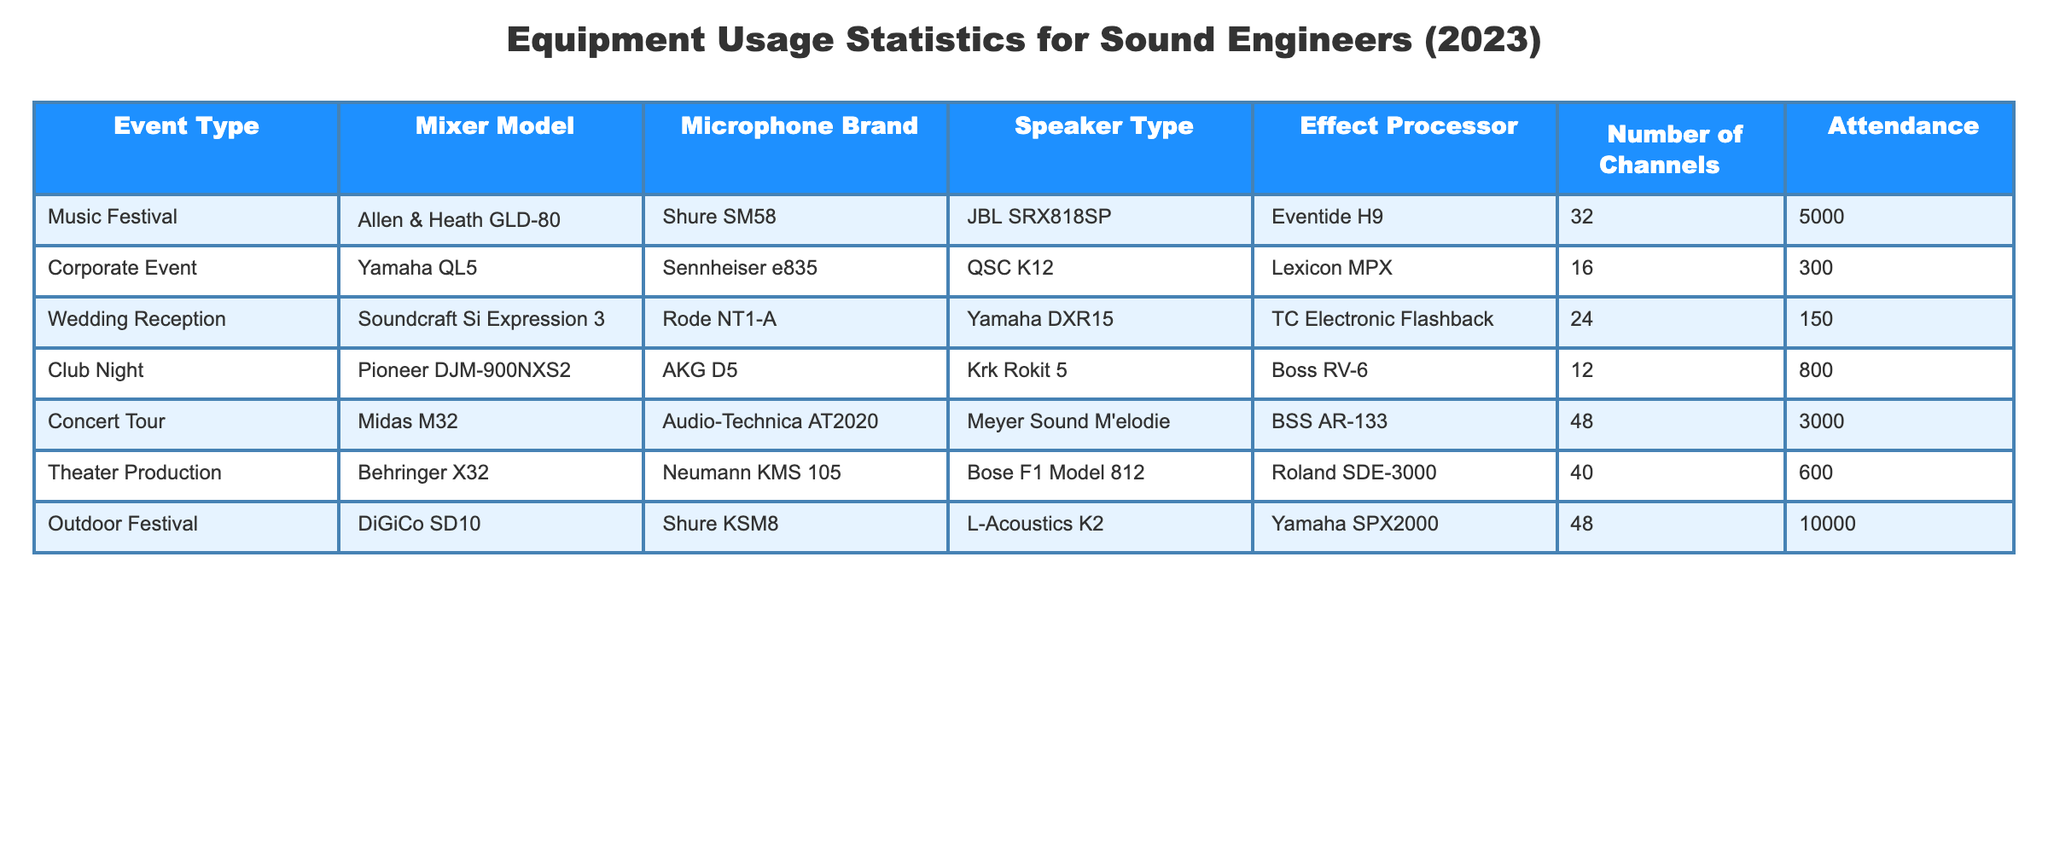What is the mixer model used for the Outdoor Festival? The table lists the equipment used for each event type. Looking at the row for the Outdoor Festival, the mixer model is DiGiCo SD10.
Answer: DiGiCo SD10 Which event type had the highest attendance? Attendance figures are presented in the table. By comparing the attendance numbers, the Outdoor Festival has the highest attendance of 10,000.
Answer: Outdoor Festival What is the average number of channels used across all events? To find the average, sum the number of channels used (32 + 16 + 24 + 12 + 48 + 40 + 48 = 220) and divide by the number of events (7). Therefore, the average is 220/7 = approximately 31.43.
Answer: 31.43 Is the microphone brand used for the Corporate Event Shure? The table specifies the microphone brand for each event. For the Corporate Event, the microphone brand is Sennheiser e835, which is not Shure.
Answer: No What is the difference in attendance between the Music Festival and the Concert Tour? To determine the difference, subtract the attendance of the Concert Tour (3000) from the Music Festival (5000). The difference is 5000 - 3000 = 2000.
Answer: 2000 Which effect processor was used for the Wedding Reception? Looking at the row for the Wedding Reception, the effect processor listed is TC Electronic Flashback.
Answer: TC Electronic Flashback Did any event types use the same Speaker Type? By analyzing the speaker types used for each event, it’s evident that both the Outdoor Festival and the Concert Tour used Meyer Sound M'elodie as the speaker type. Thus, yes, there are occurrences of same speaker types being used across different event types.
Answer: Yes What is the maximum number of channels used in any event? By reviewing the number of channels in the table, the maximum value is 48, which occurs in both the Concert Tour and the Outdoor Festival.
Answer: 48 Which two events used effect processors from the same manufacturer? The table lists effect processors used in the events. Both the Eventide H9 (used in the Music Festival) and the Boss RV-6 (used in the Club Night) are from separate manufacturers, but the Lexicon MPX (used in the Corporate Event) and the Roland SDE-3000 (used in the Theater Production) are both from Lexicon and Roland respectively. Therefore, the events that used effect processors from the same manufacturer are the Corporate Event and the Theater Production.
Answer: Corporate Event and Theater Production 